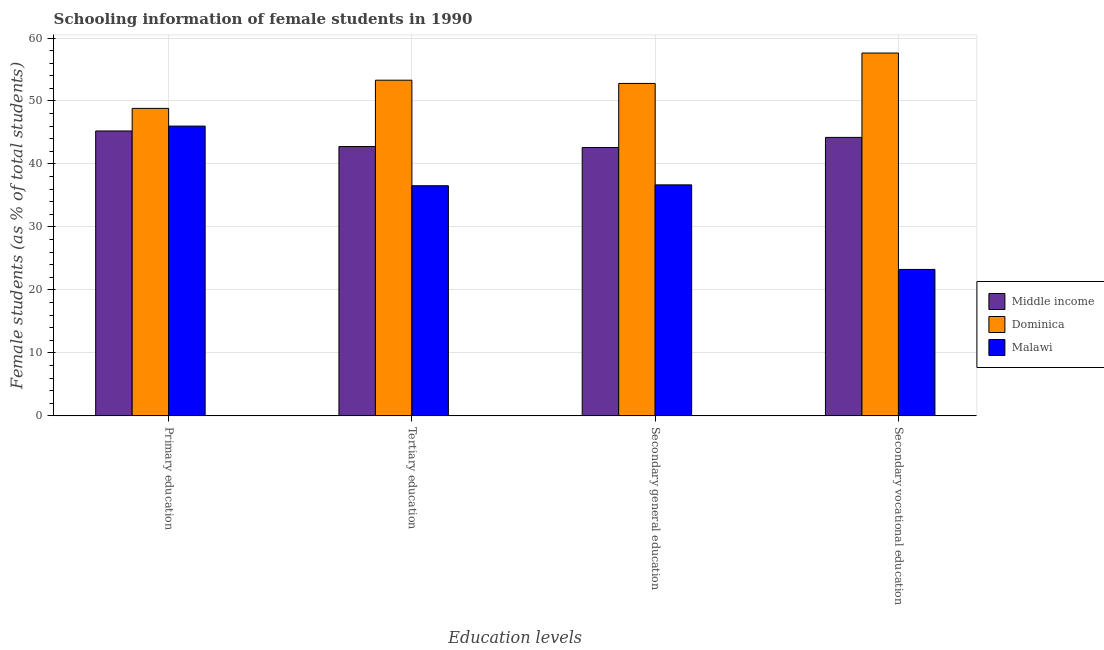How many different coloured bars are there?
Provide a short and direct response. 3. Are the number of bars per tick equal to the number of legend labels?
Your answer should be compact. Yes. Are the number of bars on each tick of the X-axis equal?
Keep it short and to the point. Yes. How many bars are there on the 4th tick from the left?
Give a very brief answer. 3. What is the label of the 3rd group of bars from the left?
Your answer should be compact. Secondary general education. What is the percentage of female students in secondary vocational education in Dominica?
Give a very brief answer. 57.62. Across all countries, what is the maximum percentage of female students in secondary education?
Offer a terse response. 52.78. Across all countries, what is the minimum percentage of female students in primary education?
Your answer should be very brief. 45.24. In which country was the percentage of female students in tertiary education maximum?
Offer a very short reply. Dominica. In which country was the percentage of female students in primary education minimum?
Give a very brief answer. Middle income. What is the total percentage of female students in secondary vocational education in the graph?
Provide a short and direct response. 125.09. What is the difference between the percentage of female students in tertiary education in Dominica and that in Malawi?
Keep it short and to the point. 16.76. What is the difference between the percentage of female students in tertiary education in Dominica and the percentage of female students in secondary vocational education in Middle income?
Give a very brief answer. 9.08. What is the average percentage of female students in secondary education per country?
Offer a very short reply. 44.03. What is the difference between the percentage of female students in primary education and percentage of female students in secondary education in Dominica?
Your answer should be compact. -3.96. What is the ratio of the percentage of female students in secondary education in Dominica to that in Malawi?
Your answer should be compact. 1.44. Is the percentage of female students in secondary vocational education in Dominica less than that in Middle income?
Provide a short and direct response. No. What is the difference between the highest and the second highest percentage of female students in tertiary education?
Offer a terse response. 10.53. What is the difference between the highest and the lowest percentage of female students in secondary education?
Ensure brevity in your answer.  16.1. Is the sum of the percentage of female students in tertiary education in Malawi and Middle income greater than the maximum percentage of female students in secondary vocational education across all countries?
Provide a short and direct response. Yes. What does the 2nd bar from the left in Tertiary education represents?
Offer a terse response. Dominica. What does the 1st bar from the right in Primary education represents?
Your answer should be very brief. Malawi. Are all the bars in the graph horizontal?
Provide a short and direct response. No. How many countries are there in the graph?
Your response must be concise. 3. Are the values on the major ticks of Y-axis written in scientific E-notation?
Make the answer very short. No. Does the graph contain any zero values?
Offer a very short reply. No. Where does the legend appear in the graph?
Ensure brevity in your answer.  Center right. How many legend labels are there?
Provide a short and direct response. 3. What is the title of the graph?
Your answer should be very brief. Schooling information of female students in 1990. Does "Brunei Darussalam" appear as one of the legend labels in the graph?
Make the answer very short. No. What is the label or title of the X-axis?
Offer a very short reply. Education levels. What is the label or title of the Y-axis?
Provide a short and direct response. Female students (as % of total students). What is the Female students (as % of total students) of Middle income in Primary education?
Provide a short and direct response. 45.24. What is the Female students (as % of total students) of Dominica in Primary education?
Offer a very short reply. 48.83. What is the Female students (as % of total students) of Malawi in Primary education?
Keep it short and to the point. 46.01. What is the Female students (as % of total students) in Middle income in Tertiary education?
Provide a short and direct response. 42.77. What is the Female students (as % of total students) in Dominica in Tertiary education?
Your answer should be very brief. 53.3. What is the Female students (as % of total students) of Malawi in Tertiary education?
Give a very brief answer. 36.54. What is the Female students (as % of total students) in Middle income in Secondary general education?
Keep it short and to the point. 42.61. What is the Female students (as % of total students) of Dominica in Secondary general education?
Your answer should be very brief. 52.78. What is the Female students (as % of total students) of Malawi in Secondary general education?
Keep it short and to the point. 36.68. What is the Female students (as % of total students) in Middle income in Secondary vocational education?
Your response must be concise. 44.22. What is the Female students (as % of total students) of Dominica in Secondary vocational education?
Your answer should be compact. 57.62. What is the Female students (as % of total students) of Malawi in Secondary vocational education?
Ensure brevity in your answer.  23.25. Across all Education levels, what is the maximum Female students (as % of total students) of Middle income?
Provide a short and direct response. 45.24. Across all Education levels, what is the maximum Female students (as % of total students) of Dominica?
Your answer should be compact. 57.62. Across all Education levels, what is the maximum Female students (as % of total students) in Malawi?
Ensure brevity in your answer.  46.01. Across all Education levels, what is the minimum Female students (as % of total students) of Middle income?
Make the answer very short. 42.61. Across all Education levels, what is the minimum Female students (as % of total students) in Dominica?
Keep it short and to the point. 48.83. Across all Education levels, what is the minimum Female students (as % of total students) in Malawi?
Your response must be concise. 23.25. What is the total Female students (as % of total students) in Middle income in the graph?
Make the answer very short. 174.84. What is the total Female students (as % of total students) in Dominica in the graph?
Give a very brief answer. 212.53. What is the total Female students (as % of total students) in Malawi in the graph?
Give a very brief answer. 142.49. What is the difference between the Female students (as % of total students) in Middle income in Primary education and that in Tertiary education?
Give a very brief answer. 2.47. What is the difference between the Female students (as % of total students) of Dominica in Primary education and that in Tertiary education?
Your answer should be very brief. -4.48. What is the difference between the Female students (as % of total students) in Malawi in Primary education and that in Tertiary education?
Offer a very short reply. 9.47. What is the difference between the Female students (as % of total students) of Middle income in Primary education and that in Secondary general education?
Offer a very short reply. 2.62. What is the difference between the Female students (as % of total students) in Dominica in Primary education and that in Secondary general education?
Offer a very short reply. -3.96. What is the difference between the Female students (as % of total students) of Malawi in Primary education and that in Secondary general education?
Ensure brevity in your answer.  9.33. What is the difference between the Female students (as % of total students) in Dominica in Primary education and that in Secondary vocational education?
Provide a short and direct response. -8.79. What is the difference between the Female students (as % of total students) of Malawi in Primary education and that in Secondary vocational education?
Your answer should be compact. 22.76. What is the difference between the Female students (as % of total students) in Middle income in Tertiary education and that in Secondary general education?
Make the answer very short. 0.16. What is the difference between the Female students (as % of total students) of Dominica in Tertiary education and that in Secondary general education?
Make the answer very short. 0.52. What is the difference between the Female students (as % of total students) of Malawi in Tertiary education and that in Secondary general education?
Provide a short and direct response. -0.14. What is the difference between the Female students (as % of total students) in Middle income in Tertiary education and that in Secondary vocational education?
Offer a terse response. -1.45. What is the difference between the Female students (as % of total students) in Dominica in Tertiary education and that in Secondary vocational education?
Provide a short and direct response. -4.31. What is the difference between the Female students (as % of total students) of Malawi in Tertiary education and that in Secondary vocational education?
Your answer should be very brief. 13.29. What is the difference between the Female students (as % of total students) in Middle income in Secondary general education and that in Secondary vocational education?
Give a very brief answer. -1.6. What is the difference between the Female students (as % of total students) in Dominica in Secondary general education and that in Secondary vocational education?
Offer a very short reply. -4.83. What is the difference between the Female students (as % of total students) of Malawi in Secondary general education and that in Secondary vocational education?
Your answer should be compact. 13.43. What is the difference between the Female students (as % of total students) of Middle income in Primary education and the Female students (as % of total students) of Dominica in Tertiary education?
Make the answer very short. -8.06. What is the difference between the Female students (as % of total students) of Middle income in Primary education and the Female students (as % of total students) of Malawi in Tertiary education?
Your answer should be compact. 8.7. What is the difference between the Female students (as % of total students) of Dominica in Primary education and the Female students (as % of total students) of Malawi in Tertiary education?
Make the answer very short. 12.28. What is the difference between the Female students (as % of total students) in Middle income in Primary education and the Female students (as % of total students) in Dominica in Secondary general education?
Keep it short and to the point. -7.55. What is the difference between the Female students (as % of total students) of Middle income in Primary education and the Female students (as % of total students) of Malawi in Secondary general education?
Provide a succinct answer. 8.56. What is the difference between the Female students (as % of total students) of Dominica in Primary education and the Female students (as % of total students) of Malawi in Secondary general education?
Provide a short and direct response. 12.15. What is the difference between the Female students (as % of total students) in Middle income in Primary education and the Female students (as % of total students) in Dominica in Secondary vocational education?
Your answer should be very brief. -12.38. What is the difference between the Female students (as % of total students) in Middle income in Primary education and the Female students (as % of total students) in Malawi in Secondary vocational education?
Keep it short and to the point. 21.98. What is the difference between the Female students (as % of total students) in Dominica in Primary education and the Female students (as % of total students) in Malawi in Secondary vocational education?
Provide a succinct answer. 25.57. What is the difference between the Female students (as % of total students) of Middle income in Tertiary education and the Female students (as % of total students) of Dominica in Secondary general education?
Your answer should be compact. -10.01. What is the difference between the Female students (as % of total students) in Middle income in Tertiary education and the Female students (as % of total students) in Malawi in Secondary general education?
Provide a succinct answer. 6.09. What is the difference between the Female students (as % of total students) of Dominica in Tertiary education and the Female students (as % of total students) of Malawi in Secondary general education?
Ensure brevity in your answer.  16.62. What is the difference between the Female students (as % of total students) in Middle income in Tertiary education and the Female students (as % of total students) in Dominica in Secondary vocational education?
Make the answer very short. -14.85. What is the difference between the Female students (as % of total students) in Middle income in Tertiary education and the Female students (as % of total students) in Malawi in Secondary vocational education?
Your response must be concise. 19.51. What is the difference between the Female students (as % of total students) in Dominica in Tertiary education and the Female students (as % of total students) in Malawi in Secondary vocational education?
Offer a very short reply. 30.05. What is the difference between the Female students (as % of total students) in Middle income in Secondary general education and the Female students (as % of total students) in Dominica in Secondary vocational education?
Your response must be concise. -15. What is the difference between the Female students (as % of total students) in Middle income in Secondary general education and the Female students (as % of total students) in Malawi in Secondary vocational education?
Provide a succinct answer. 19.36. What is the difference between the Female students (as % of total students) of Dominica in Secondary general education and the Female students (as % of total students) of Malawi in Secondary vocational education?
Ensure brevity in your answer.  29.53. What is the average Female students (as % of total students) in Middle income per Education levels?
Your answer should be very brief. 43.71. What is the average Female students (as % of total students) in Dominica per Education levels?
Give a very brief answer. 53.13. What is the average Female students (as % of total students) in Malawi per Education levels?
Ensure brevity in your answer.  35.62. What is the difference between the Female students (as % of total students) in Middle income and Female students (as % of total students) in Dominica in Primary education?
Provide a succinct answer. -3.59. What is the difference between the Female students (as % of total students) in Middle income and Female students (as % of total students) in Malawi in Primary education?
Give a very brief answer. -0.78. What is the difference between the Female students (as % of total students) in Dominica and Female students (as % of total students) in Malawi in Primary education?
Your answer should be very brief. 2.81. What is the difference between the Female students (as % of total students) in Middle income and Female students (as % of total students) in Dominica in Tertiary education?
Your answer should be very brief. -10.53. What is the difference between the Female students (as % of total students) of Middle income and Female students (as % of total students) of Malawi in Tertiary education?
Make the answer very short. 6.23. What is the difference between the Female students (as % of total students) in Dominica and Female students (as % of total students) in Malawi in Tertiary education?
Offer a very short reply. 16.76. What is the difference between the Female students (as % of total students) in Middle income and Female students (as % of total students) in Dominica in Secondary general education?
Your answer should be very brief. -10.17. What is the difference between the Female students (as % of total students) of Middle income and Female students (as % of total students) of Malawi in Secondary general education?
Ensure brevity in your answer.  5.93. What is the difference between the Female students (as % of total students) in Dominica and Female students (as % of total students) in Malawi in Secondary general education?
Ensure brevity in your answer.  16.1. What is the difference between the Female students (as % of total students) of Middle income and Female students (as % of total students) of Dominica in Secondary vocational education?
Give a very brief answer. -13.4. What is the difference between the Female students (as % of total students) of Middle income and Female students (as % of total students) of Malawi in Secondary vocational education?
Give a very brief answer. 20.96. What is the difference between the Female students (as % of total students) in Dominica and Female students (as % of total students) in Malawi in Secondary vocational education?
Keep it short and to the point. 34.36. What is the ratio of the Female students (as % of total students) of Middle income in Primary education to that in Tertiary education?
Your answer should be compact. 1.06. What is the ratio of the Female students (as % of total students) in Dominica in Primary education to that in Tertiary education?
Provide a succinct answer. 0.92. What is the ratio of the Female students (as % of total students) in Malawi in Primary education to that in Tertiary education?
Your answer should be very brief. 1.26. What is the ratio of the Female students (as % of total students) of Middle income in Primary education to that in Secondary general education?
Your answer should be very brief. 1.06. What is the ratio of the Female students (as % of total students) in Dominica in Primary education to that in Secondary general education?
Your response must be concise. 0.93. What is the ratio of the Female students (as % of total students) in Malawi in Primary education to that in Secondary general education?
Provide a short and direct response. 1.25. What is the ratio of the Female students (as % of total students) in Middle income in Primary education to that in Secondary vocational education?
Make the answer very short. 1.02. What is the ratio of the Female students (as % of total students) of Dominica in Primary education to that in Secondary vocational education?
Make the answer very short. 0.85. What is the ratio of the Female students (as % of total students) in Malawi in Primary education to that in Secondary vocational education?
Provide a succinct answer. 1.98. What is the ratio of the Female students (as % of total students) in Dominica in Tertiary education to that in Secondary general education?
Give a very brief answer. 1.01. What is the ratio of the Female students (as % of total students) of Malawi in Tertiary education to that in Secondary general education?
Ensure brevity in your answer.  1. What is the ratio of the Female students (as % of total students) of Middle income in Tertiary education to that in Secondary vocational education?
Make the answer very short. 0.97. What is the ratio of the Female students (as % of total students) of Dominica in Tertiary education to that in Secondary vocational education?
Offer a very short reply. 0.93. What is the ratio of the Female students (as % of total students) of Malawi in Tertiary education to that in Secondary vocational education?
Make the answer very short. 1.57. What is the ratio of the Female students (as % of total students) of Middle income in Secondary general education to that in Secondary vocational education?
Your response must be concise. 0.96. What is the ratio of the Female students (as % of total students) in Dominica in Secondary general education to that in Secondary vocational education?
Offer a very short reply. 0.92. What is the ratio of the Female students (as % of total students) of Malawi in Secondary general education to that in Secondary vocational education?
Ensure brevity in your answer.  1.58. What is the difference between the highest and the second highest Female students (as % of total students) of Dominica?
Give a very brief answer. 4.31. What is the difference between the highest and the second highest Female students (as % of total students) of Malawi?
Give a very brief answer. 9.33. What is the difference between the highest and the lowest Female students (as % of total students) in Middle income?
Your response must be concise. 2.62. What is the difference between the highest and the lowest Female students (as % of total students) in Dominica?
Ensure brevity in your answer.  8.79. What is the difference between the highest and the lowest Female students (as % of total students) of Malawi?
Offer a terse response. 22.76. 